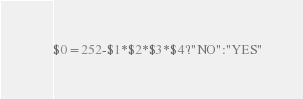Convert code to text. <code><loc_0><loc_0><loc_500><loc_500><_Awk_>$0=252-$1*$2*$3*$4?"NO":"YES"</code> 